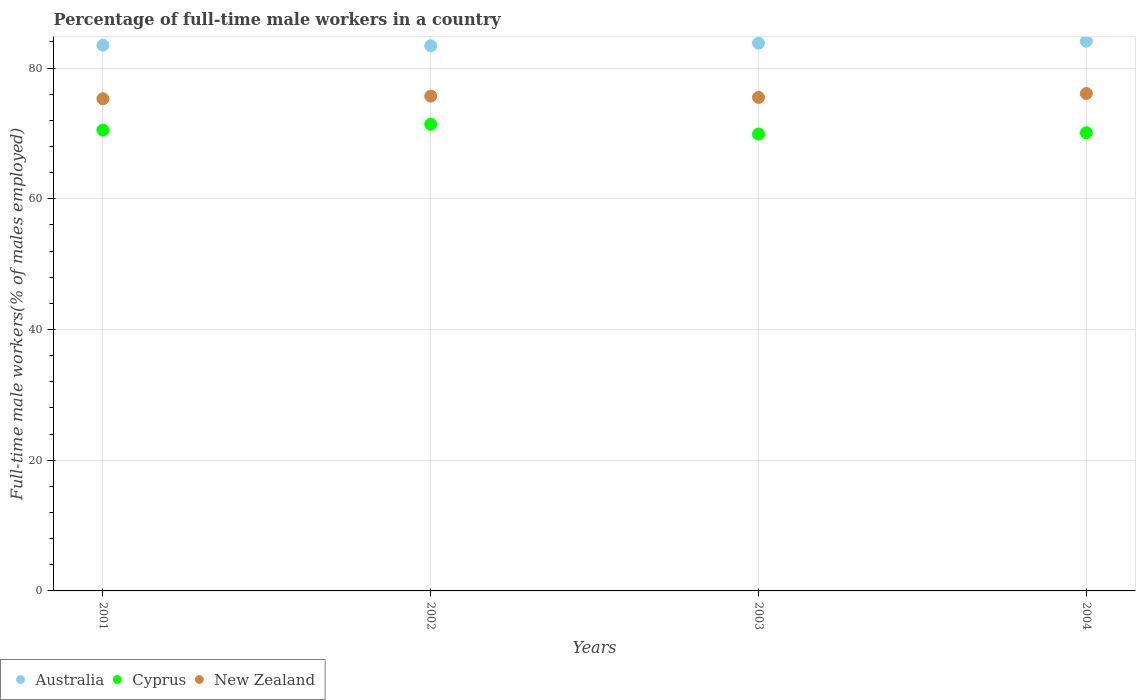How many different coloured dotlines are there?
Ensure brevity in your answer.  3. What is the percentage of full-time male workers in Cyprus in 2003?
Keep it short and to the point. 69.9. Across all years, what is the maximum percentage of full-time male workers in Australia?
Offer a very short reply. 84.1. Across all years, what is the minimum percentage of full-time male workers in New Zealand?
Offer a very short reply. 75.3. In which year was the percentage of full-time male workers in Cyprus maximum?
Offer a terse response. 2002. What is the total percentage of full-time male workers in New Zealand in the graph?
Offer a terse response. 302.6. What is the difference between the percentage of full-time male workers in Cyprus in 2002 and that in 2004?
Provide a short and direct response. 1.3. What is the difference between the percentage of full-time male workers in Cyprus in 2004 and the percentage of full-time male workers in New Zealand in 2003?
Offer a very short reply. -5.4. What is the average percentage of full-time male workers in Australia per year?
Your answer should be compact. 83.7. What is the ratio of the percentage of full-time male workers in Australia in 2002 to that in 2004?
Ensure brevity in your answer.  0.99. Is the difference between the percentage of full-time male workers in Cyprus in 2002 and 2003 greater than the difference between the percentage of full-time male workers in Australia in 2002 and 2003?
Your answer should be very brief. Yes. What is the difference between the highest and the second highest percentage of full-time male workers in New Zealand?
Your answer should be very brief. 0.4. What is the difference between the highest and the lowest percentage of full-time male workers in Australia?
Your response must be concise. 0.7. Is it the case that in every year, the sum of the percentage of full-time male workers in Cyprus and percentage of full-time male workers in Australia  is greater than the percentage of full-time male workers in New Zealand?
Provide a short and direct response. Yes. Is the percentage of full-time male workers in Australia strictly greater than the percentage of full-time male workers in Cyprus over the years?
Provide a succinct answer. Yes. How many dotlines are there?
Ensure brevity in your answer.  3. What is the difference between two consecutive major ticks on the Y-axis?
Your answer should be very brief. 20. Are the values on the major ticks of Y-axis written in scientific E-notation?
Give a very brief answer. No. How many legend labels are there?
Provide a succinct answer. 3. How are the legend labels stacked?
Provide a short and direct response. Horizontal. What is the title of the graph?
Offer a terse response. Percentage of full-time male workers in a country. What is the label or title of the X-axis?
Give a very brief answer. Years. What is the label or title of the Y-axis?
Give a very brief answer. Full-time male workers(% of males employed). What is the Full-time male workers(% of males employed) of Australia in 2001?
Provide a short and direct response. 83.5. What is the Full-time male workers(% of males employed) in Cyprus in 2001?
Offer a very short reply. 70.5. What is the Full-time male workers(% of males employed) of New Zealand in 2001?
Your response must be concise. 75.3. What is the Full-time male workers(% of males employed) in Australia in 2002?
Your answer should be very brief. 83.4. What is the Full-time male workers(% of males employed) of Cyprus in 2002?
Provide a succinct answer. 71.4. What is the Full-time male workers(% of males employed) in New Zealand in 2002?
Give a very brief answer. 75.7. What is the Full-time male workers(% of males employed) of Australia in 2003?
Provide a succinct answer. 83.8. What is the Full-time male workers(% of males employed) of Cyprus in 2003?
Offer a very short reply. 69.9. What is the Full-time male workers(% of males employed) in New Zealand in 2003?
Provide a succinct answer. 75.5. What is the Full-time male workers(% of males employed) of Australia in 2004?
Offer a very short reply. 84.1. What is the Full-time male workers(% of males employed) in Cyprus in 2004?
Offer a very short reply. 70.1. What is the Full-time male workers(% of males employed) in New Zealand in 2004?
Provide a succinct answer. 76.1. Across all years, what is the maximum Full-time male workers(% of males employed) in Australia?
Your answer should be compact. 84.1. Across all years, what is the maximum Full-time male workers(% of males employed) of Cyprus?
Make the answer very short. 71.4. Across all years, what is the maximum Full-time male workers(% of males employed) in New Zealand?
Your response must be concise. 76.1. Across all years, what is the minimum Full-time male workers(% of males employed) of Australia?
Ensure brevity in your answer.  83.4. Across all years, what is the minimum Full-time male workers(% of males employed) in Cyprus?
Provide a succinct answer. 69.9. Across all years, what is the minimum Full-time male workers(% of males employed) of New Zealand?
Offer a very short reply. 75.3. What is the total Full-time male workers(% of males employed) of Australia in the graph?
Your response must be concise. 334.8. What is the total Full-time male workers(% of males employed) in Cyprus in the graph?
Your answer should be very brief. 281.9. What is the total Full-time male workers(% of males employed) of New Zealand in the graph?
Your answer should be compact. 302.6. What is the difference between the Full-time male workers(% of males employed) of Cyprus in 2001 and that in 2002?
Your response must be concise. -0.9. What is the difference between the Full-time male workers(% of males employed) of Australia in 2001 and that in 2004?
Provide a short and direct response. -0.6. What is the difference between the Full-time male workers(% of males employed) in New Zealand in 2001 and that in 2004?
Offer a very short reply. -0.8. What is the difference between the Full-time male workers(% of males employed) of Australia in 2002 and that in 2003?
Your response must be concise. -0.4. What is the difference between the Full-time male workers(% of males employed) in Cyprus in 2002 and that in 2003?
Offer a very short reply. 1.5. What is the difference between the Full-time male workers(% of males employed) in New Zealand in 2002 and that in 2003?
Offer a very short reply. 0.2. What is the difference between the Full-time male workers(% of males employed) in Australia in 2002 and that in 2004?
Ensure brevity in your answer.  -0.7. What is the difference between the Full-time male workers(% of males employed) in Cyprus in 2002 and that in 2004?
Offer a terse response. 1.3. What is the difference between the Full-time male workers(% of males employed) in Australia in 2003 and that in 2004?
Keep it short and to the point. -0.3. What is the difference between the Full-time male workers(% of males employed) in New Zealand in 2003 and that in 2004?
Your response must be concise. -0.6. What is the difference between the Full-time male workers(% of males employed) in Australia in 2001 and the Full-time male workers(% of males employed) in Cyprus in 2003?
Make the answer very short. 13.6. What is the difference between the Full-time male workers(% of males employed) of Cyprus in 2001 and the Full-time male workers(% of males employed) of New Zealand in 2003?
Keep it short and to the point. -5. What is the difference between the Full-time male workers(% of males employed) in Australia in 2001 and the Full-time male workers(% of males employed) in New Zealand in 2004?
Ensure brevity in your answer.  7.4. What is the difference between the Full-time male workers(% of males employed) of Cyprus in 2001 and the Full-time male workers(% of males employed) of New Zealand in 2004?
Ensure brevity in your answer.  -5.6. What is the difference between the Full-time male workers(% of males employed) in Australia in 2002 and the Full-time male workers(% of males employed) in Cyprus in 2003?
Your response must be concise. 13.5. What is the difference between the Full-time male workers(% of males employed) of Australia in 2002 and the Full-time male workers(% of males employed) of New Zealand in 2003?
Your answer should be compact. 7.9. What is the difference between the Full-time male workers(% of males employed) of Australia in 2002 and the Full-time male workers(% of males employed) of Cyprus in 2004?
Your response must be concise. 13.3. What is the difference between the Full-time male workers(% of males employed) in Cyprus in 2002 and the Full-time male workers(% of males employed) in New Zealand in 2004?
Your response must be concise. -4.7. What is the difference between the Full-time male workers(% of males employed) in Australia in 2003 and the Full-time male workers(% of males employed) in New Zealand in 2004?
Your answer should be very brief. 7.7. What is the difference between the Full-time male workers(% of males employed) in Cyprus in 2003 and the Full-time male workers(% of males employed) in New Zealand in 2004?
Offer a very short reply. -6.2. What is the average Full-time male workers(% of males employed) in Australia per year?
Ensure brevity in your answer.  83.7. What is the average Full-time male workers(% of males employed) in Cyprus per year?
Keep it short and to the point. 70.47. What is the average Full-time male workers(% of males employed) in New Zealand per year?
Your answer should be compact. 75.65. In the year 2001, what is the difference between the Full-time male workers(% of males employed) in Australia and Full-time male workers(% of males employed) in New Zealand?
Keep it short and to the point. 8.2. In the year 2002, what is the difference between the Full-time male workers(% of males employed) in Australia and Full-time male workers(% of males employed) in Cyprus?
Your answer should be compact. 12. In the year 2002, what is the difference between the Full-time male workers(% of males employed) of Australia and Full-time male workers(% of males employed) of New Zealand?
Provide a short and direct response. 7.7. In the year 2002, what is the difference between the Full-time male workers(% of males employed) of Cyprus and Full-time male workers(% of males employed) of New Zealand?
Your answer should be compact. -4.3. In the year 2003, what is the difference between the Full-time male workers(% of males employed) in Australia and Full-time male workers(% of males employed) in Cyprus?
Give a very brief answer. 13.9. In the year 2004, what is the difference between the Full-time male workers(% of males employed) in Australia and Full-time male workers(% of males employed) in Cyprus?
Your answer should be very brief. 14. In the year 2004, what is the difference between the Full-time male workers(% of males employed) of Cyprus and Full-time male workers(% of males employed) of New Zealand?
Your answer should be very brief. -6. What is the ratio of the Full-time male workers(% of males employed) of Australia in 2001 to that in 2002?
Give a very brief answer. 1. What is the ratio of the Full-time male workers(% of males employed) in Cyprus in 2001 to that in 2002?
Make the answer very short. 0.99. What is the ratio of the Full-time male workers(% of males employed) in Cyprus in 2001 to that in 2003?
Offer a very short reply. 1.01. What is the ratio of the Full-time male workers(% of males employed) of Cyprus in 2001 to that in 2004?
Make the answer very short. 1.01. What is the ratio of the Full-time male workers(% of males employed) of New Zealand in 2001 to that in 2004?
Provide a short and direct response. 0.99. What is the ratio of the Full-time male workers(% of males employed) in Cyprus in 2002 to that in 2003?
Keep it short and to the point. 1.02. What is the ratio of the Full-time male workers(% of males employed) of Cyprus in 2002 to that in 2004?
Keep it short and to the point. 1.02. What is the ratio of the Full-time male workers(% of males employed) of New Zealand in 2002 to that in 2004?
Ensure brevity in your answer.  0.99. What is the ratio of the Full-time male workers(% of males employed) of Australia in 2003 to that in 2004?
Provide a succinct answer. 1. What is the ratio of the Full-time male workers(% of males employed) of New Zealand in 2003 to that in 2004?
Provide a succinct answer. 0.99. What is the difference between the highest and the second highest Full-time male workers(% of males employed) in Australia?
Offer a terse response. 0.3. What is the difference between the highest and the second highest Full-time male workers(% of males employed) of Cyprus?
Offer a very short reply. 0.9. What is the difference between the highest and the lowest Full-time male workers(% of males employed) in Cyprus?
Ensure brevity in your answer.  1.5. What is the difference between the highest and the lowest Full-time male workers(% of males employed) of New Zealand?
Your answer should be very brief. 0.8. 